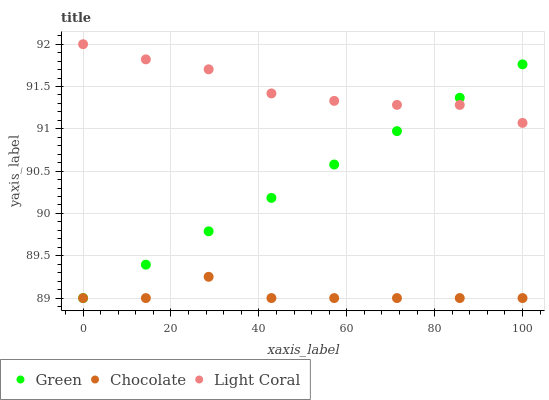Does Chocolate have the minimum area under the curve?
Answer yes or no. Yes. Does Light Coral have the maximum area under the curve?
Answer yes or no. Yes. Does Green have the minimum area under the curve?
Answer yes or no. No. Does Green have the maximum area under the curve?
Answer yes or no. No. Is Green the smoothest?
Answer yes or no. Yes. Is Chocolate the roughest?
Answer yes or no. Yes. Is Chocolate the smoothest?
Answer yes or no. No. Is Green the roughest?
Answer yes or no. No. Does Green have the lowest value?
Answer yes or no. Yes. Does Light Coral have the highest value?
Answer yes or no. Yes. Does Green have the highest value?
Answer yes or no. No. Is Chocolate less than Light Coral?
Answer yes or no. Yes. Is Light Coral greater than Chocolate?
Answer yes or no. Yes. Does Light Coral intersect Green?
Answer yes or no. Yes. Is Light Coral less than Green?
Answer yes or no. No. Is Light Coral greater than Green?
Answer yes or no. No. Does Chocolate intersect Light Coral?
Answer yes or no. No. 